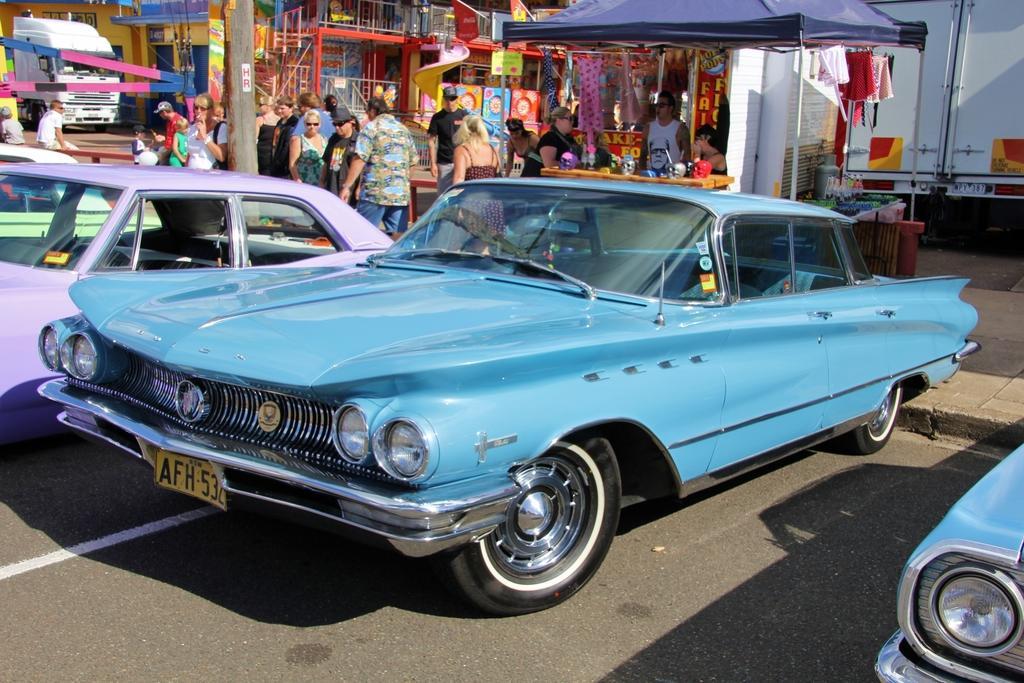Could you give a brief overview of what you see in this image? Here we can see cars on the road. In the background there are few persons standing and few are sitting and we can see buildings,vehicles,tents,stores,staircase,a person selling clothes and other objects. 